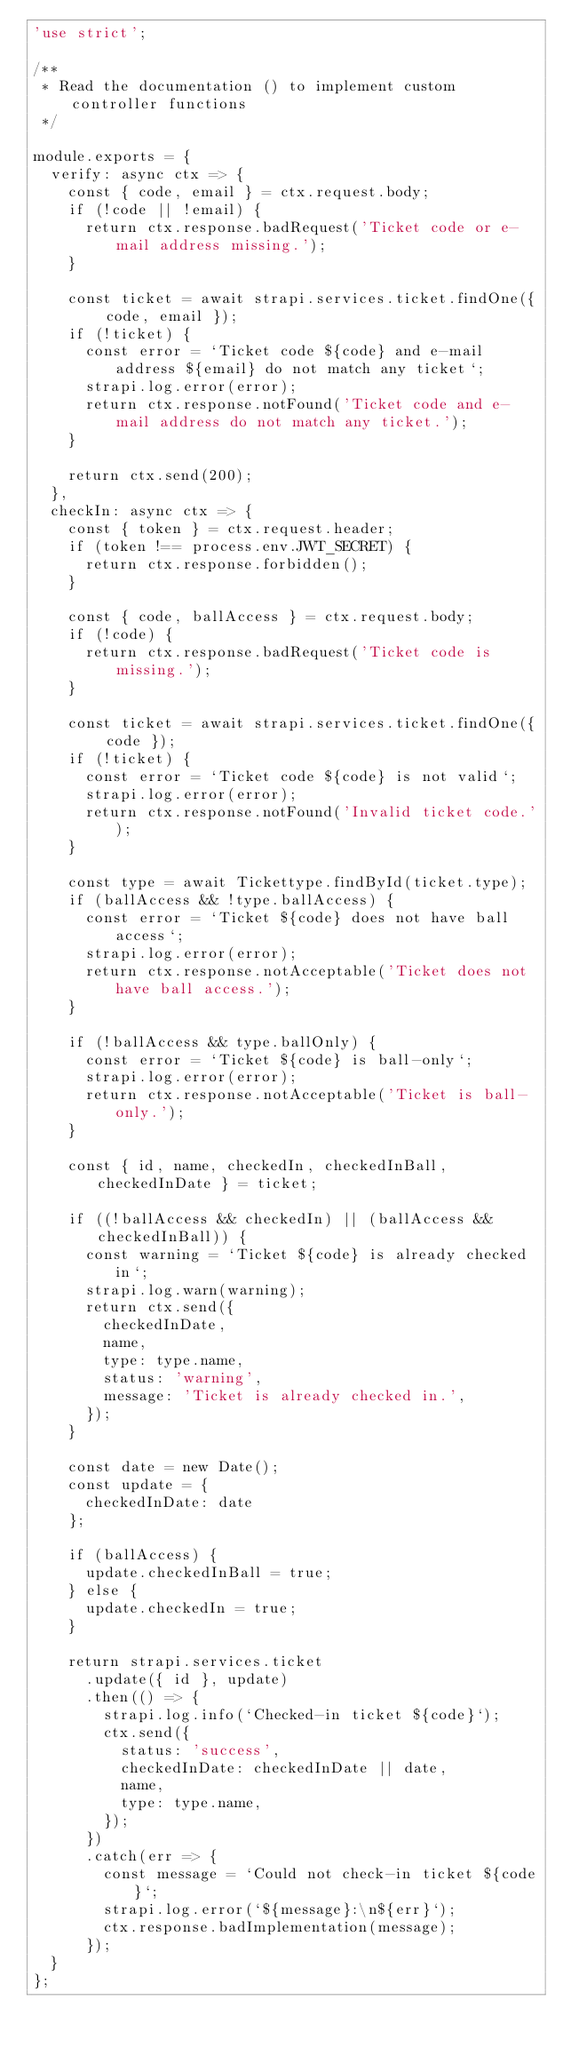<code> <loc_0><loc_0><loc_500><loc_500><_JavaScript_>'use strict';

/**
 * Read the documentation () to implement custom controller functions
 */

module.exports = {
  verify: async ctx => {
    const { code, email } = ctx.request.body;
    if (!code || !email) {
      return ctx.response.badRequest('Ticket code or e-mail address missing.');
    }

    const ticket = await strapi.services.ticket.findOne({ code, email });
    if (!ticket) {
      const error = `Ticket code ${code} and e-mail address ${email} do not match any ticket`;
      strapi.log.error(error);
      return ctx.response.notFound('Ticket code and e-mail address do not match any ticket.');
    }

    return ctx.send(200);
  },
  checkIn: async ctx => {
    const { token } = ctx.request.header;
    if (token !== process.env.JWT_SECRET) {
      return ctx.response.forbidden();
    }

    const { code, ballAccess } = ctx.request.body;
    if (!code) {
      return ctx.response.badRequest('Ticket code is missing.');
    }

    const ticket = await strapi.services.ticket.findOne({ code });
    if (!ticket) {
      const error = `Ticket code ${code} is not valid`;
      strapi.log.error(error);
      return ctx.response.notFound('Invalid ticket code.');
    }

    const type = await Tickettype.findById(ticket.type);
    if (ballAccess && !type.ballAccess) {
      const error = `Ticket ${code} does not have ball access`;
      strapi.log.error(error);
      return ctx.response.notAcceptable('Ticket does not have ball access.');
    }

    if (!ballAccess && type.ballOnly) {
      const error = `Ticket ${code} is ball-only`;
      strapi.log.error(error);
      return ctx.response.notAcceptable('Ticket is ball-only.');
    }

    const { id, name, checkedIn, checkedInBall, checkedInDate } = ticket;

    if ((!ballAccess && checkedIn) || (ballAccess && checkedInBall)) {
      const warning = `Ticket ${code} is already checked in`;
      strapi.log.warn(warning);
      return ctx.send({
        checkedInDate,
        name,
        type: type.name,
        status: 'warning',
        message: 'Ticket is already checked in.',
      });
    }

    const date = new Date();
    const update = {
      checkedInDate: date
    };

    if (ballAccess) {
      update.checkedInBall = true;
    } else {
      update.checkedIn = true;
    }

    return strapi.services.ticket
      .update({ id }, update)
      .then(() => {
        strapi.log.info(`Checked-in ticket ${code}`);
        ctx.send({
          status: 'success',
          checkedInDate: checkedInDate || date,
          name,
          type: type.name,
        });
      })
      .catch(err => {
        const message = `Could not check-in ticket ${code}`;
        strapi.log.error(`${message}:\n${err}`);
        ctx.response.badImplementation(message);
      });
  }
};
</code> 